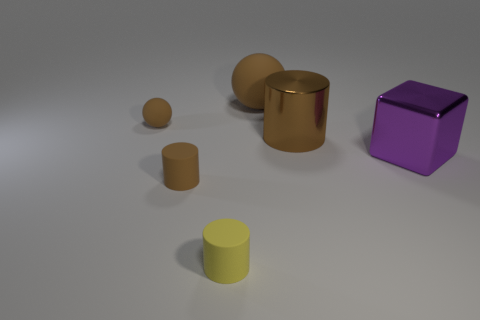What number of big blocks have the same material as the large purple object?
Make the answer very short. 0. Is the number of big things left of the large purple cube greater than the number of large rubber balls?
Your answer should be compact. Yes. There is a metallic object that is the same color as the small sphere; what size is it?
Ensure brevity in your answer.  Large. Are there any other shiny objects of the same shape as the small yellow thing?
Offer a terse response. Yes. What number of things are either yellow shiny cylinders or shiny things?
Keep it short and to the point. 2. What number of brown spheres are to the right of the ball left of the big rubber sphere that is behind the purple thing?
Provide a succinct answer. 1. What is the material of the big object that is the same shape as the small yellow rubber thing?
Your answer should be compact. Metal. What material is the cylinder that is on the right side of the small brown cylinder and left of the brown shiny object?
Make the answer very short. Rubber. Is the number of small brown rubber things that are on the right side of the large purple block less than the number of brown objects on the left side of the big brown matte ball?
Make the answer very short. Yes. There is a big thing in front of the big brown object that is on the right side of the rubber ball that is to the right of the small yellow rubber object; what shape is it?
Give a very brief answer. Cube. 